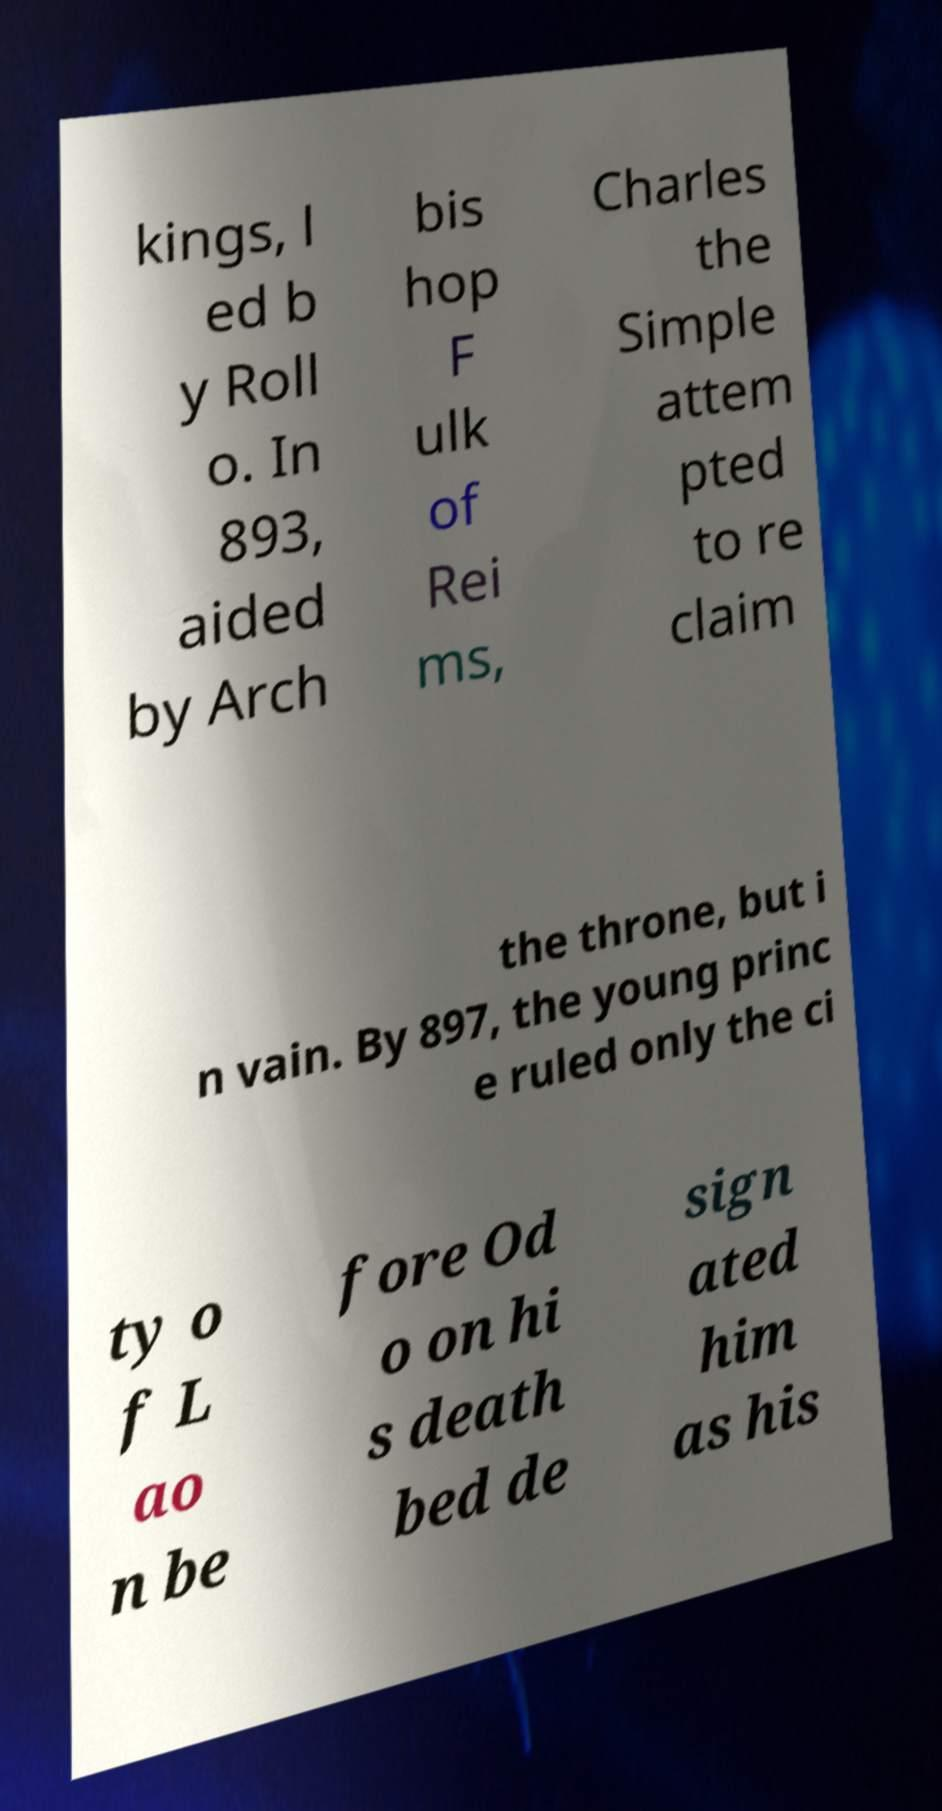Please identify and transcribe the text found in this image. kings, l ed b y Roll o. In 893, aided by Arch bis hop F ulk of Rei ms, Charles the Simple attem pted to re claim the throne, but i n vain. By 897, the young princ e ruled only the ci ty o f L ao n be fore Od o on hi s death bed de sign ated him as his 